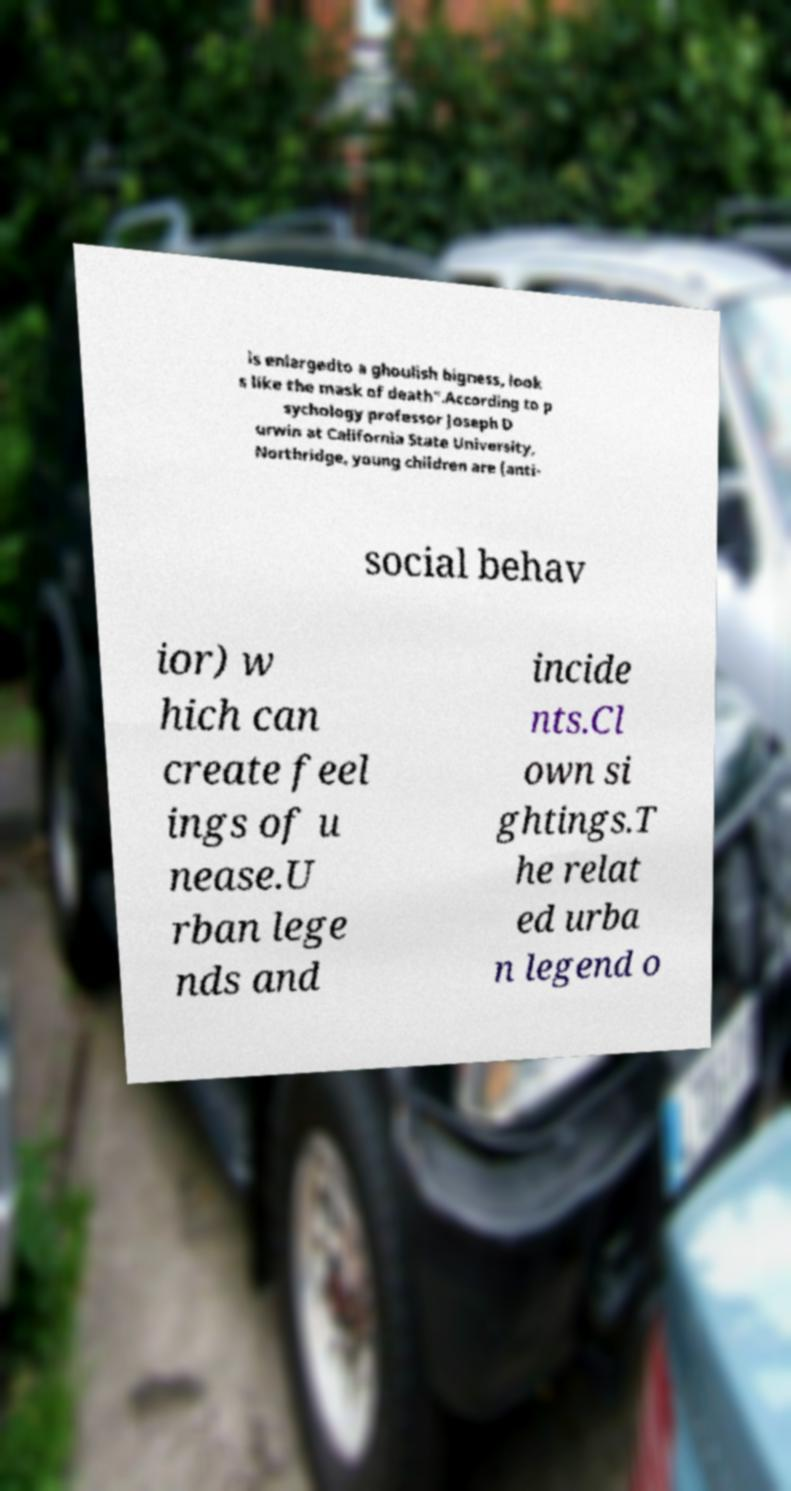For documentation purposes, I need the text within this image transcribed. Could you provide that? is enlargedto a ghoulish bigness, look s like the mask of death".According to p sychology professor Joseph D urwin at California State University, Northridge, young children are (anti- social behav ior) w hich can create feel ings of u nease.U rban lege nds and incide nts.Cl own si ghtings.T he relat ed urba n legend o 